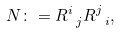<formula> <loc_0><loc_0><loc_500><loc_500>N \colon = R ^ { i } _ { \ j } R ^ { j } _ { \ i } ,</formula> 